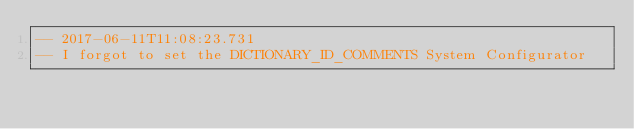<code> <loc_0><loc_0><loc_500><loc_500><_SQL_>-- 2017-06-11T11:08:23.731
-- I forgot to set the DICTIONARY_ID_COMMENTS System Configurator</code> 